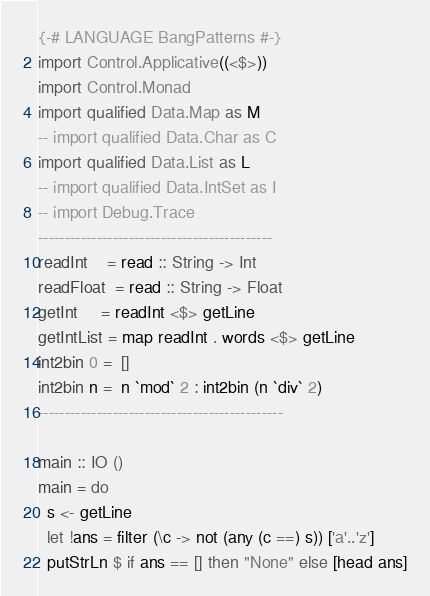<code> <loc_0><loc_0><loc_500><loc_500><_Haskell_>{-# LANGUAGE BangPatterns #-}
import Control.Applicative((<$>))
import Control.Monad
import qualified Data.Map as M
-- import qualified Data.Char as C
import qualified Data.List as L
-- import qualified Data.IntSet as I
-- import Debug.Trace
--------------------------------------------
readInt    = read :: String -> Int
readFloat  = read :: String -> Float
getInt     = readInt <$> getLine
getIntList = map readInt . words <$> getLine
int2bin 0 =  []
int2bin n =  n `mod` 2 : int2bin (n `div` 2)
----------------------------------------------

main :: IO ()
main = do
  s <- getLine
  let !ans = filter (\c -> not (any (c ==) s)) ['a'..'z']
  putStrLn $ if ans == [] then "None" else [head ans]
</code> 